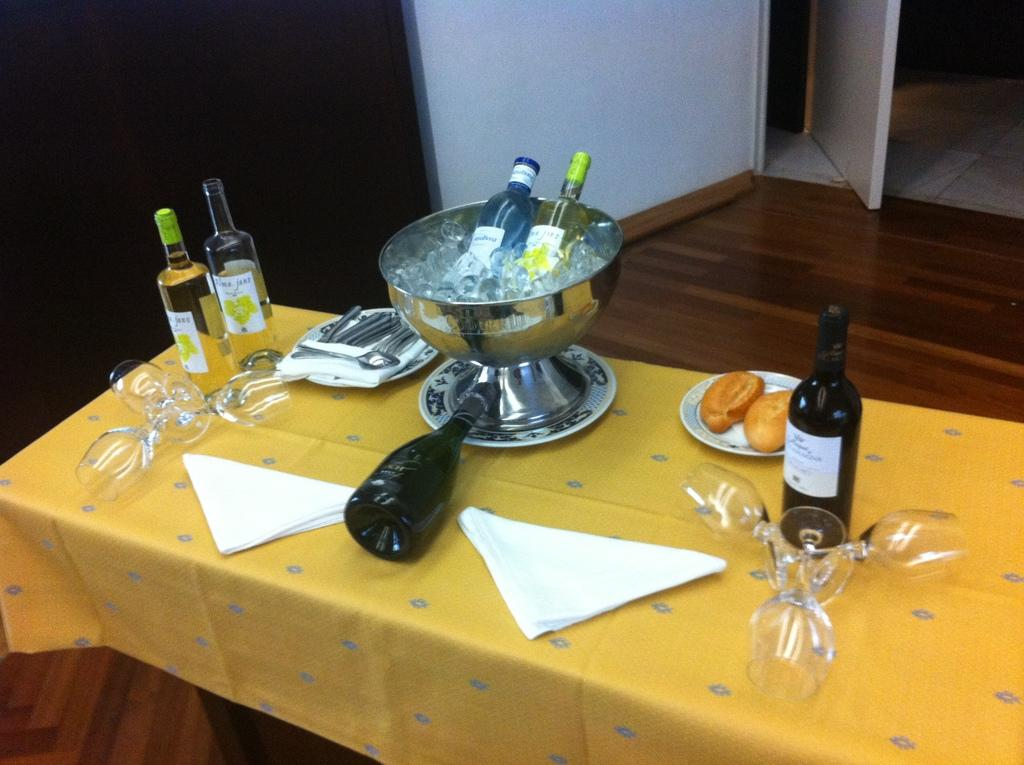What type of objects can be seen on the table in the image? There are bottles, glasses, a paper, and a bowl on the table in the image. What is the purpose of the glasses in the image? The glasses are likely used for drinking or holding liquids. Can you describe the background of the image? There is a wall and a door in the background of the image. What might the paper be used for in the image? The paper could be used for writing, drawing, or as a placemat. What type of tools does the carpenter use in the image? There is no carpenter present in the image, so it is not possible to determine what tools they might use. 